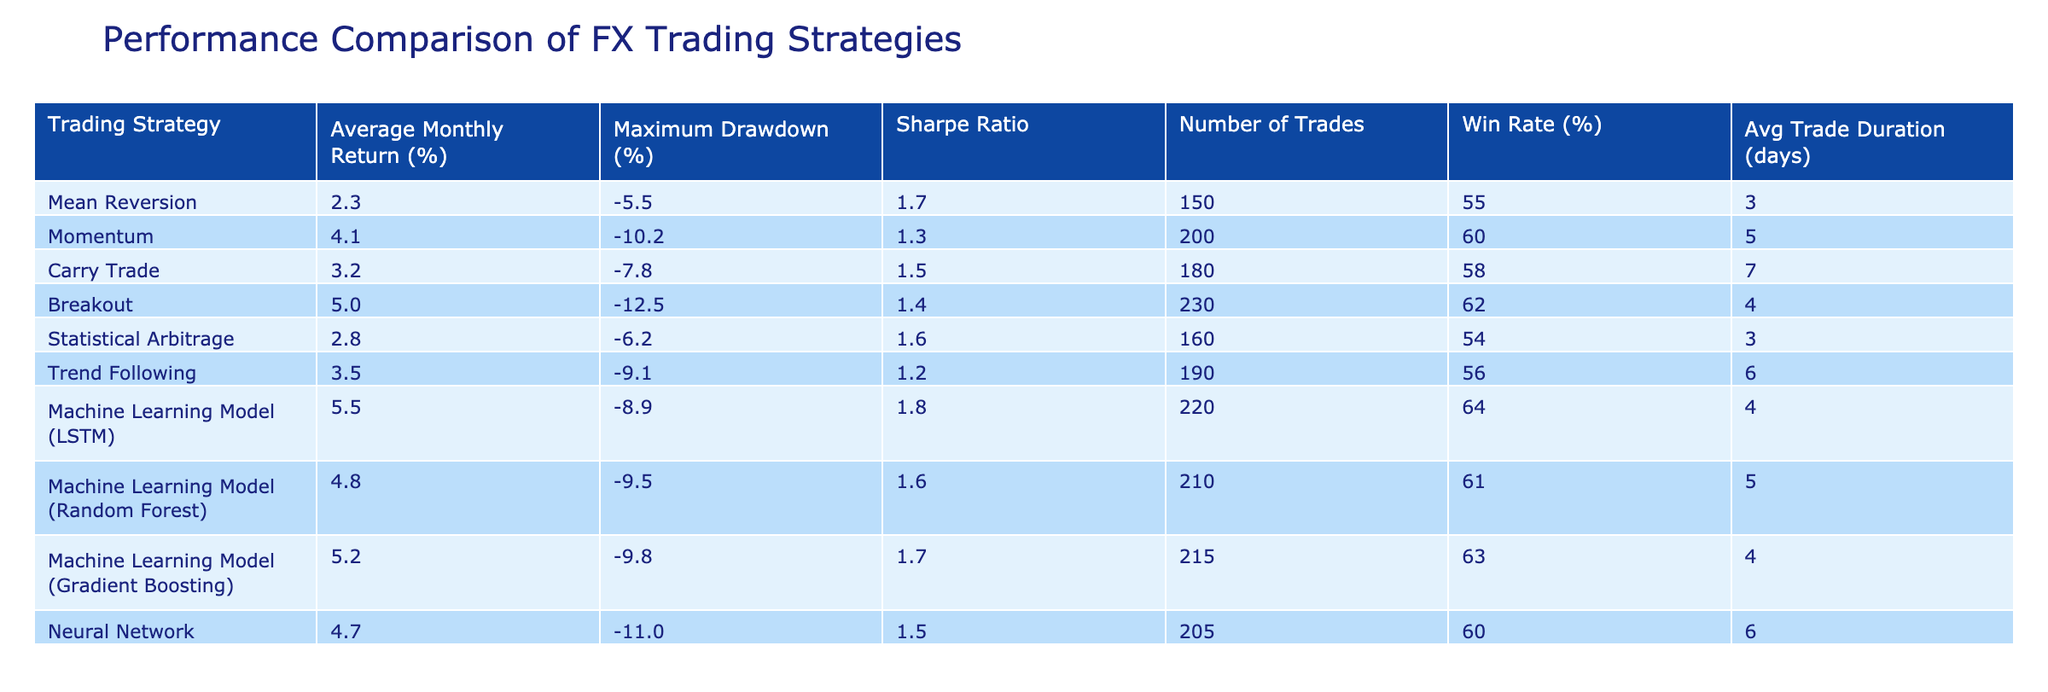What is the average monthly return of the Breakout strategy? The average monthly return is listed in the table under the column "Average Monthly Return (%)" for the Breakout strategy row. The value is 5.0%.
Answer: 5.0% Which strategy has the highest Sharpe Ratio and what is its value? To find the highest Sharpe Ratio, I examined the "Sharpe Ratio" column across all strategies. The Machine Learning Model (LSTM) has the highest Sharpe Ratio at 1.8.
Answer: Machine Learning Model (LSTM), 1.8 Is the win rate of the Carry Trade strategy more than 50%? The win rate for the Carry Trade strategy is given in the table, and the value is 58%, which is higher than 50%.
Answer: Yes Calculate the average maximum drawdown of all strategies listed in the table. The maximum drawdown values are: -5.5, -10.2, -7.8, -12.5, -6.2, -9.1, -8.9, -9.5, -9.8, -11.0. Summing them gives -9.0, and there are 10 strategies, so the average is -9.0 / 10 = -9.0%.
Answer: -9.0% Which strategies have a win rate greater than the average win rate of all strategies? To find this, I first calculated the average win rate by summing the win rates: (55 + 60 + 58 + 62 + 54 + 56 + 64 + 61 + 63 + 60) = 610, then divided by 10 to get 61%. The strategies with win rates above 61% are the Breakout (62%) and Machine Learning Model (LSTM) (64%).
Answer: Breakout, Machine Learning Model (LSTM) What is the average trade duration for the Momentum strategy? The average trade duration for the Momentum strategy is listed directly in the table under "Avg Trade Duration (days)", which is 5 days.
Answer: 5 Does the Neural Network strategy have a higher maximum drawdown than the average maximum drawdown of the listed strategies? The maximum drawdown for the Neural Network is -11.0%, while the average maximum drawdown calculated before is -9.0%. Since -11.0% is lower than -9.0%, it does have a higher value.
Answer: Yes Which strategy requires the fewest number of trades? By reviewing the "Number of Trades" column, the strategy with the fewest trades is Statistical Arbitrage with 160 trades.
Answer: Statistical Arbitrage Is the average monthly return of the Gradient Boosting model greater than the average monthly return of the Mean Reversion strategy? The average monthly return of the Gradient Boosting model is 5.2% while the Mean Reversion strategy has an average return of 2.3%. Since 5.2% is higher than 2.3%, the statement is true.
Answer: Yes 